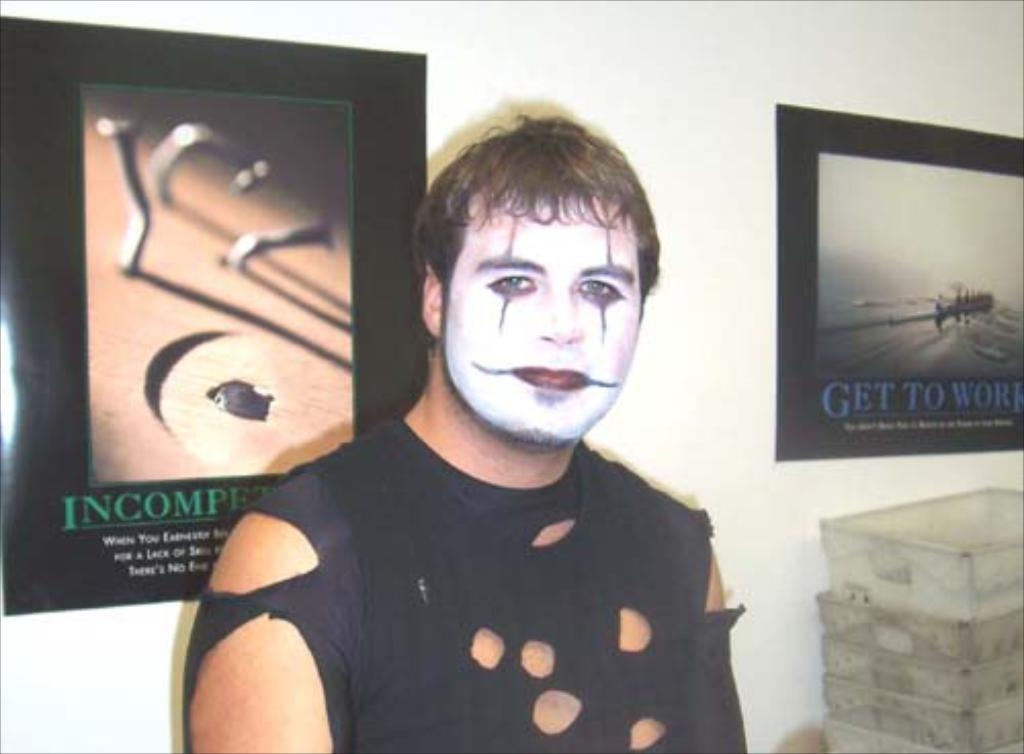What is the man in the image doing? The man is standing in the image. Can you describe the man's clothing? The man is wearing a torn shirt. What is on the man's face? There is a painting on the man's face. What can be seen in the background of the image? There are photo frames on the wall in the background of the image. What type of cork can be seen in the man's hand in the image? There is no cork present in the image; the man's hands are not visible. What color is the crayon that the man is using to draw on the wall in the image? There is no crayon or drawing on the wall in the image. 